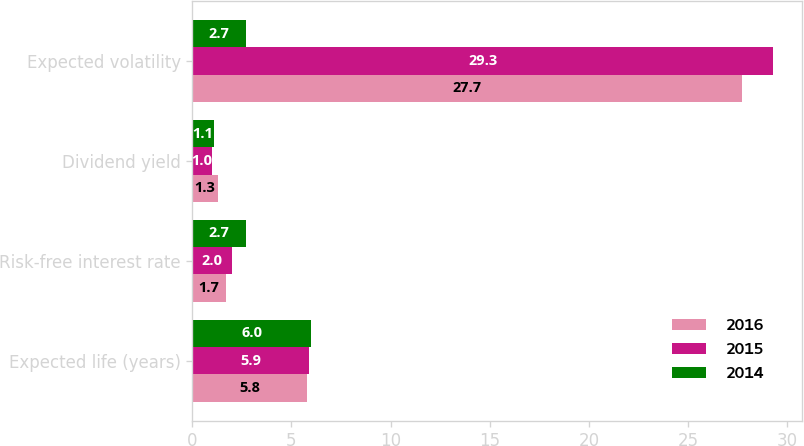<chart> <loc_0><loc_0><loc_500><loc_500><stacked_bar_chart><ecel><fcel>Expected life (years)<fcel>Risk-free interest rate<fcel>Dividend yield<fcel>Expected volatility<nl><fcel>2016<fcel>5.8<fcel>1.7<fcel>1.3<fcel>27.7<nl><fcel>2015<fcel>5.9<fcel>2<fcel>1<fcel>29.3<nl><fcel>2014<fcel>6<fcel>2.7<fcel>1.1<fcel>2.7<nl></chart> 